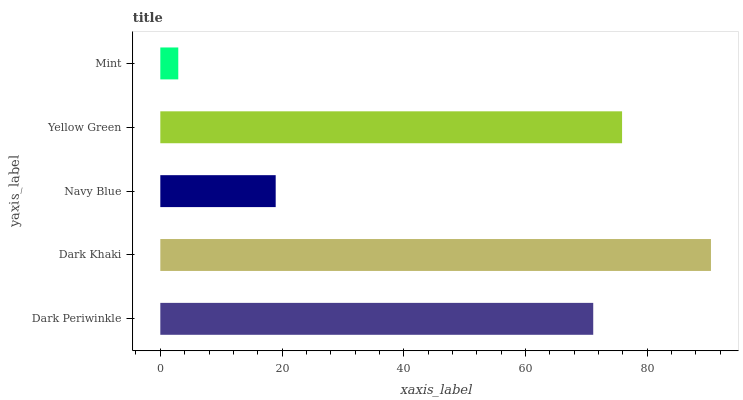Is Mint the minimum?
Answer yes or no. Yes. Is Dark Khaki the maximum?
Answer yes or no. Yes. Is Navy Blue the minimum?
Answer yes or no. No. Is Navy Blue the maximum?
Answer yes or no. No. Is Dark Khaki greater than Navy Blue?
Answer yes or no. Yes. Is Navy Blue less than Dark Khaki?
Answer yes or no. Yes. Is Navy Blue greater than Dark Khaki?
Answer yes or no. No. Is Dark Khaki less than Navy Blue?
Answer yes or no. No. Is Dark Periwinkle the high median?
Answer yes or no. Yes. Is Dark Periwinkle the low median?
Answer yes or no. Yes. Is Dark Khaki the high median?
Answer yes or no. No. Is Mint the low median?
Answer yes or no. No. 